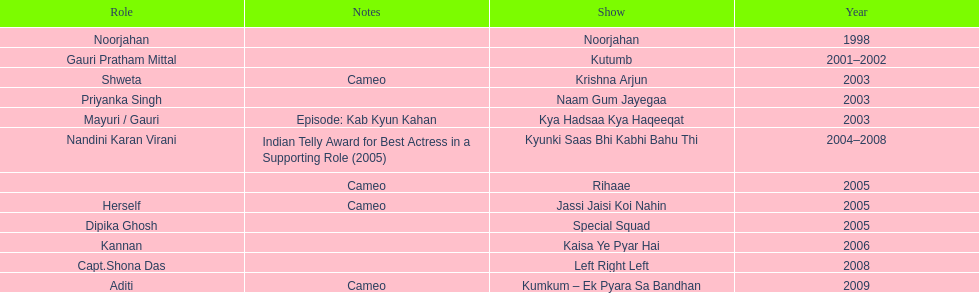How many different tv shows was gauri tejwani in before 2000? 1. 